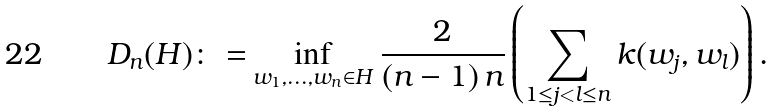Convert formula to latex. <formula><loc_0><loc_0><loc_500><loc_500>D _ { n } ( H ) \colon = & \inf _ { w _ { 1 } , \dots , w _ { n } \in H } { \frac { 2 } { ( n - 1 ) \, n } } \left ( \sum _ { 1 \leq j < l \leq n } k ( w _ { j } , w _ { l } ) \right ) .</formula> 